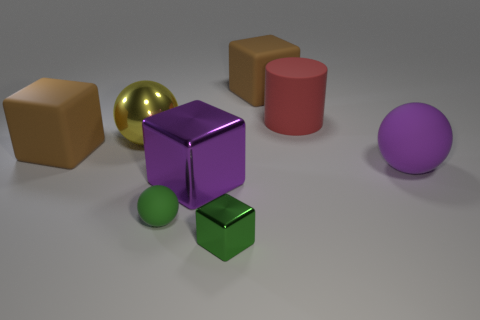Is there any pattern to the arrangement of the objects? The objects do not seem to follow a specific pattern; they are scattered across the plane randomly. However, they are all placed with enough space between them, which provides a clear view of each object's shape and color. Do the shadows tell us anything about the lighting in the scene? Yes, the shadows cast by the objects are fairly soft and extend to the right, indicating that there's a diffuse light source coming from the left side of the scene. It creates a calm atmosphere and gives depth to the arrangement. 